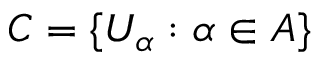<formula> <loc_0><loc_0><loc_500><loc_500>C = \{ U _ { \alpha } \colon \alpha \in A \}</formula> 